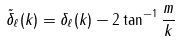Convert formula to latex. <formula><loc_0><loc_0><loc_500><loc_500>\tilde { \delta } _ { \ell } ( k ) = \delta _ { \ell } ( k ) - 2 \tan ^ { - 1 } \frac { m } { k }</formula> 